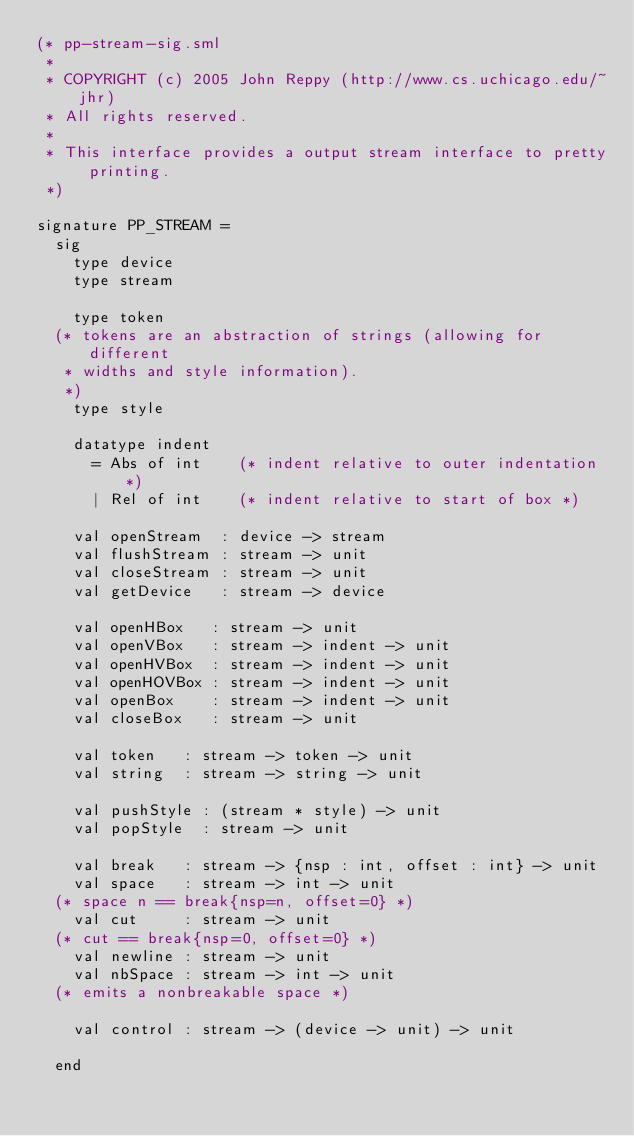Convert code to text. <code><loc_0><loc_0><loc_500><loc_500><_SML_>(* pp-stream-sig.sml
 *
 * COPYRIGHT (c) 2005 John Reppy (http://www.cs.uchicago.edu/~jhr)
 * All rights reserved.
 *
 * This interface provides a output stream interface to pretty printing.
 *)

signature PP_STREAM =
  sig
    type device
    type stream

    type token
	(* tokens are an abstraction of strings (allowing for different
	 * widths and style information).
	 *)
    type style

    datatype indent
      = Abs of int		(* indent relative to outer indentation *)
      | Rel of int		(* indent relative to start of box *)

    val openStream  : device -> stream
    val flushStream : stream -> unit
    val closeStream : stream -> unit
    val getDevice   : stream -> device

    val openHBox   : stream -> unit
    val openVBox   : stream -> indent -> unit
    val openHVBox  : stream -> indent -> unit
    val openHOVBox : stream -> indent -> unit
    val openBox    : stream -> indent -> unit
    val closeBox   : stream -> unit

    val token   : stream -> token -> unit
    val string  : stream -> string -> unit

    val pushStyle : (stream * style) -> unit
    val popStyle  : stream -> unit

    val break   : stream -> {nsp : int, offset : int} -> unit
    val space   : stream -> int -> unit
	(* space n == break{nsp=n, offset=0} *)
    val cut     : stream -> unit
	(* cut == break{nsp=0, offset=0} *)
    val newline : stream -> unit
    val nbSpace : stream -> int -> unit
	(* emits a nonbreakable space *)

    val control : stream -> (device -> unit) -> unit

  end

</code> 